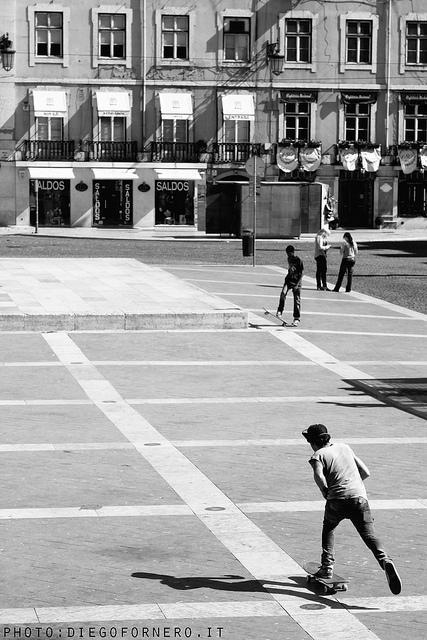How many windows are there?
Give a very brief answer. 14. 